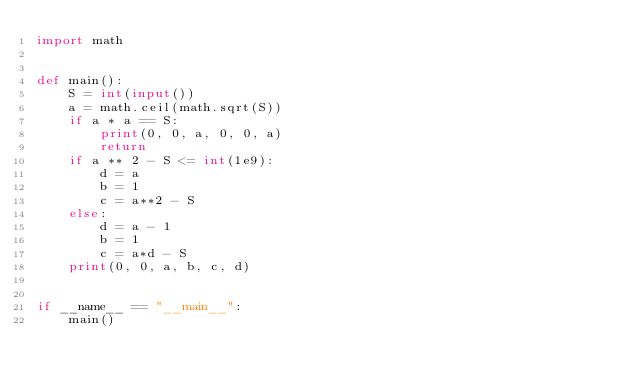<code> <loc_0><loc_0><loc_500><loc_500><_Python_>import math


def main():
    S = int(input())
    a = math.ceil(math.sqrt(S))
    if a * a == S:
        print(0, 0, a, 0, 0, a)
        return
    if a ** 2 - S <= int(1e9):
        d = a
        b = 1
        c = a**2 - S
    else:
        d = a - 1
        b = 1
        c = a*d - S
    print(0, 0, a, b, c, d)


if __name__ == "__main__":
    main()
</code> 